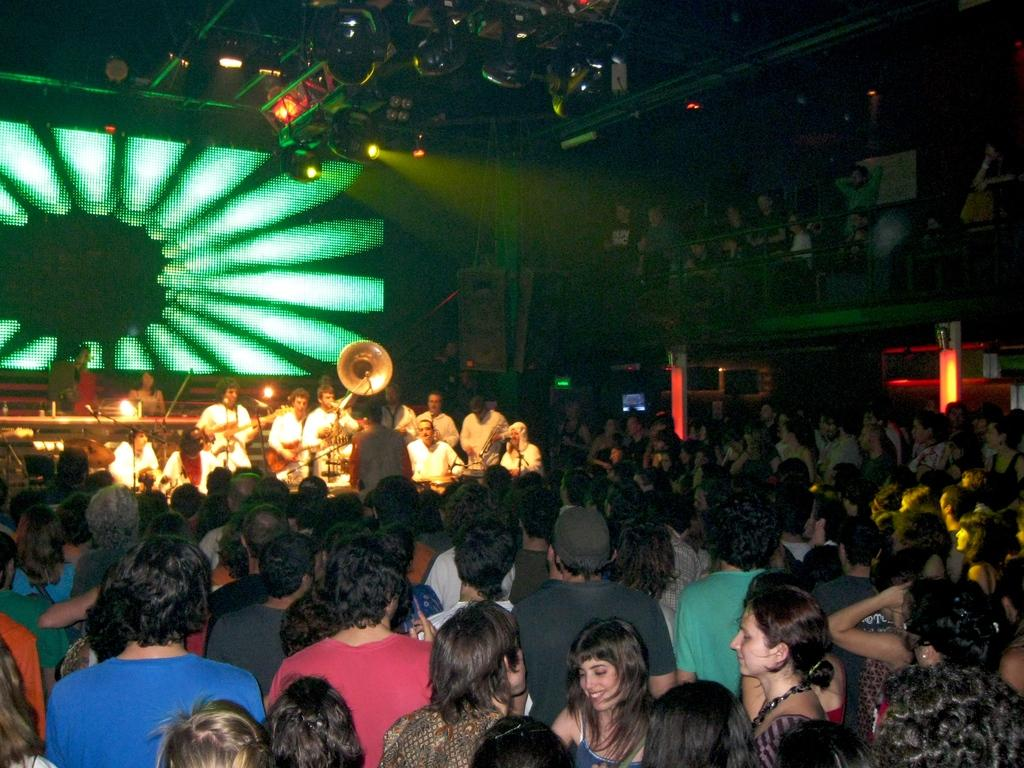How many people are in the image? There is a group of people in the image, but the exact number cannot be determined from the provided facts. What are the people in the image doing? The presence of musical instruments in the image suggests that the people might be playing music. What can be seen in the background of the image? There is a screen visible in the background of the image. What type of lighting is present in the image? Focusing lights are present at the top of the image. Can you see any rabbits playing with plants in the image? There is no mention of rabbits or plants in the provided facts, so we cannot determine their presence in the image. 